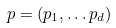Convert formula to latex. <formula><loc_0><loc_0><loc_500><loc_500>p = ( p _ { 1 } , \dots p _ { d } )</formula> 